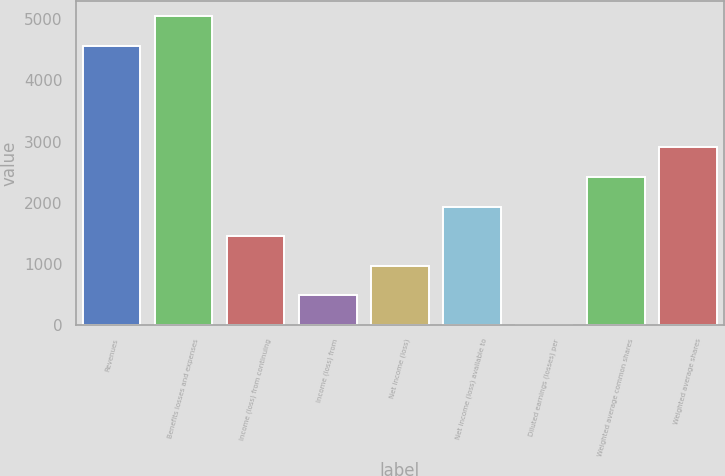<chart> <loc_0><loc_0><loc_500><loc_500><bar_chart><fcel>Revenues<fcel>Benefits losses and expenses<fcel>Income (loss) from continuing<fcel>Income (loss) from<fcel>Net income (loss)<fcel>Net income (loss) available to<fcel>Diluted earnings (losses) per<fcel>Weighted average common shares<fcel>Weighted average shares<nl><fcel>4565<fcel>5048.87<fcel>1451.87<fcel>484.13<fcel>968<fcel>1935.74<fcel>0.26<fcel>2419.61<fcel>2903.48<nl></chart> 